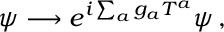Convert formula to latex. <formula><loc_0><loc_0><loc_500><loc_500>\psi \longrightarrow e ^ { i \sum _ { a } g _ { a } T ^ { a } } \psi \, ,</formula> 